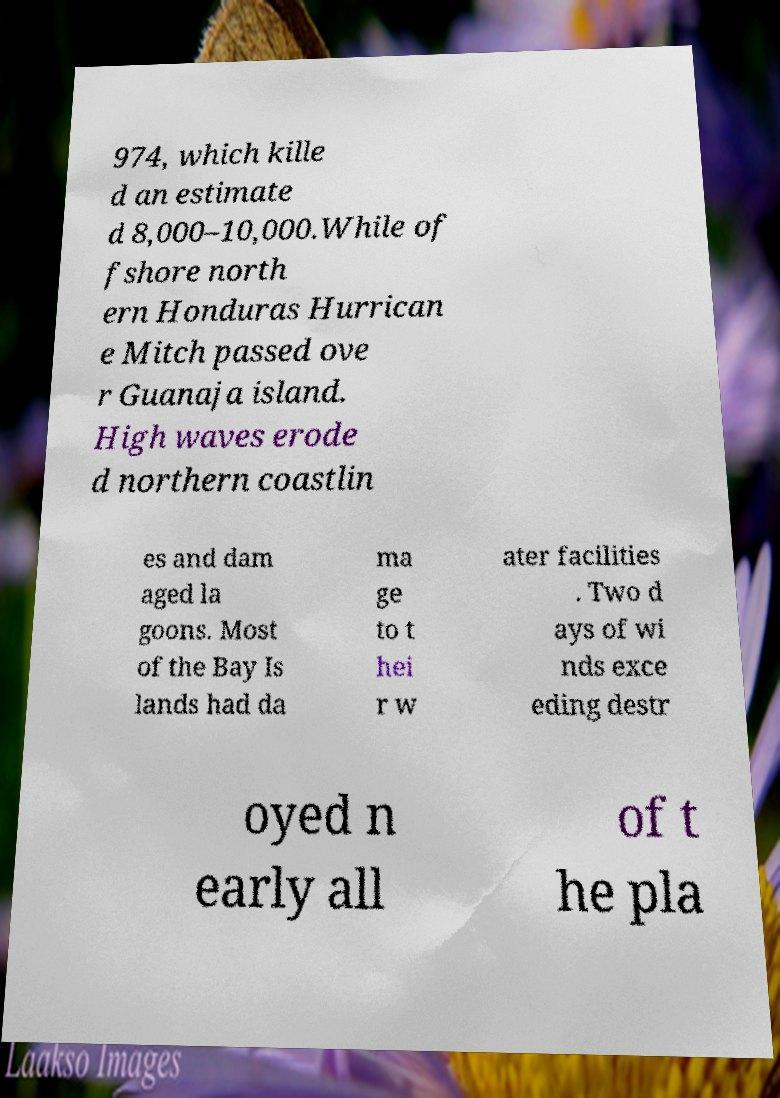Could you assist in decoding the text presented in this image and type it out clearly? 974, which kille d an estimate d 8,000–10,000.While of fshore north ern Honduras Hurrican e Mitch passed ove r Guanaja island. High waves erode d northern coastlin es and dam aged la goons. Most of the Bay Is lands had da ma ge to t hei r w ater facilities . Two d ays of wi nds exce eding destr oyed n early all of t he pla 